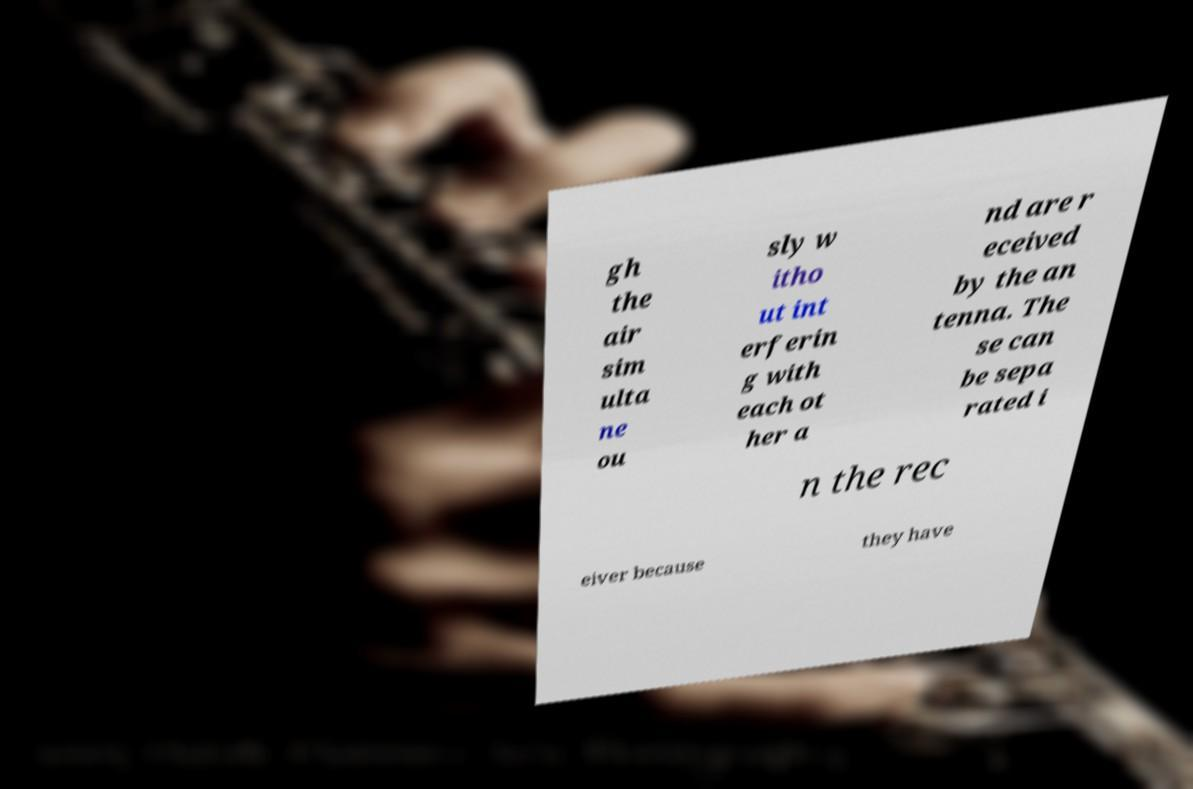I need the written content from this picture converted into text. Can you do that? gh the air sim ulta ne ou sly w itho ut int erferin g with each ot her a nd are r eceived by the an tenna. The se can be sepa rated i n the rec eiver because they have 